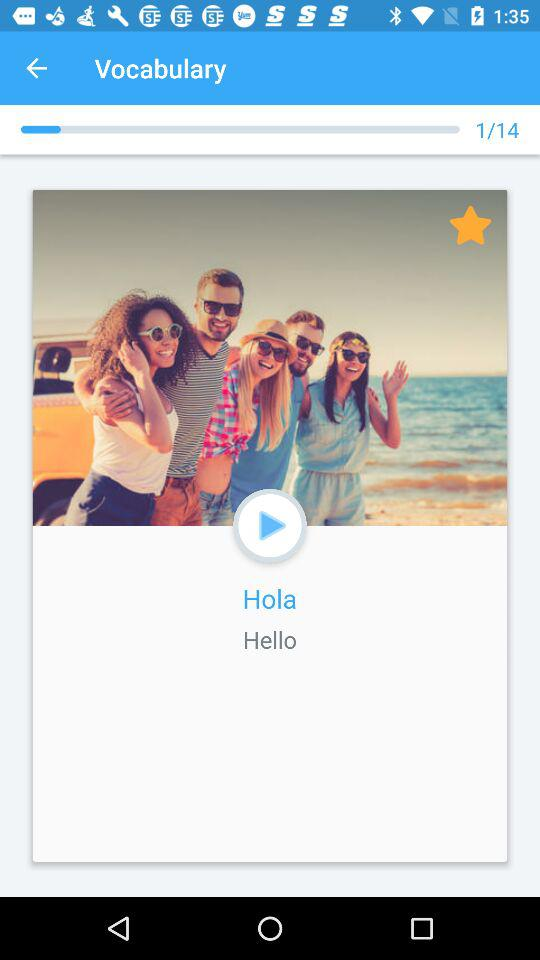At which stage am I? You are at the first stage. 